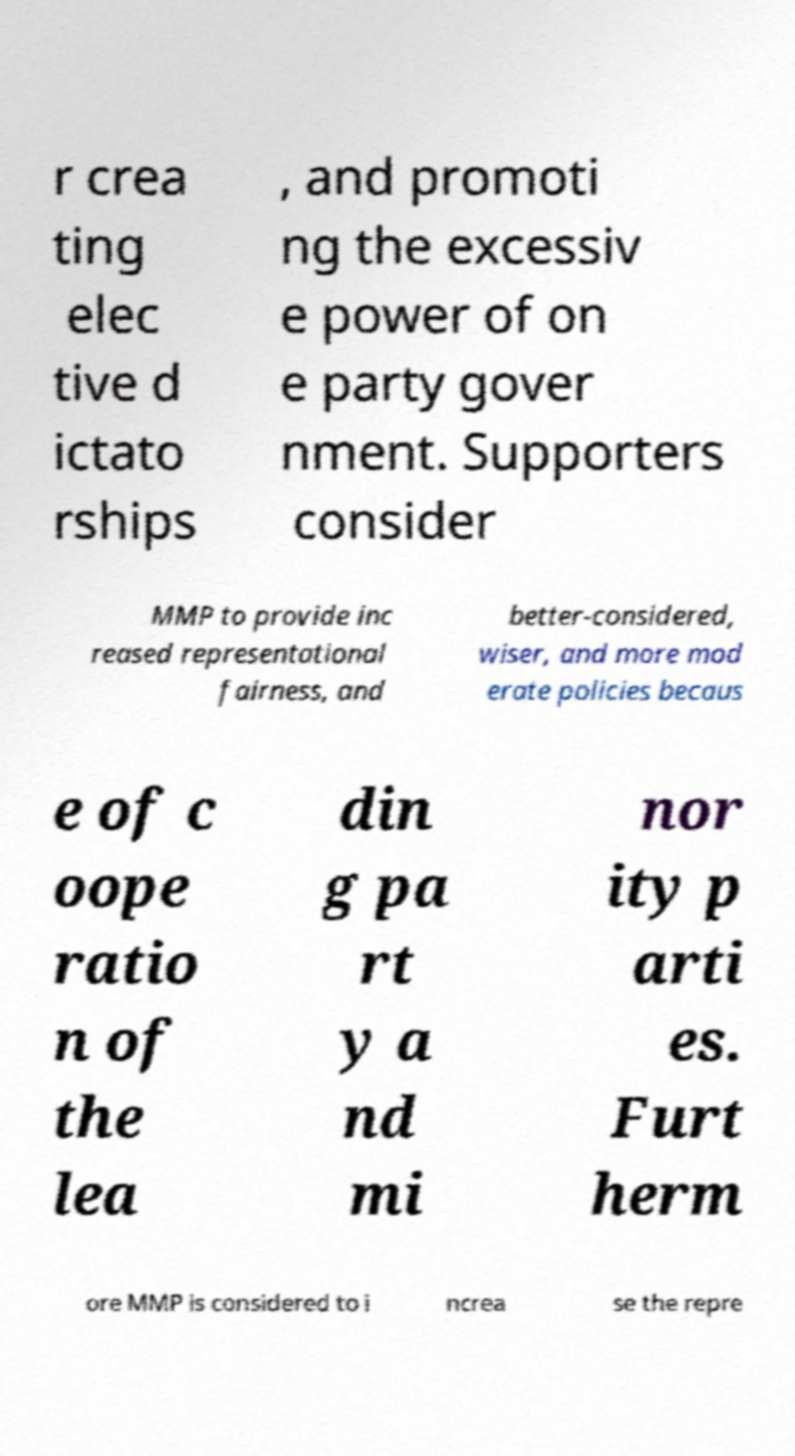What messages or text are displayed in this image? I need them in a readable, typed format. r crea ting elec tive d ictato rships , and promoti ng the excessiv e power of on e party gover nment. Supporters consider MMP to provide inc reased representational fairness, and better-considered, wiser, and more mod erate policies becaus e of c oope ratio n of the lea din g pa rt y a nd mi nor ity p arti es. Furt herm ore MMP is considered to i ncrea se the repre 